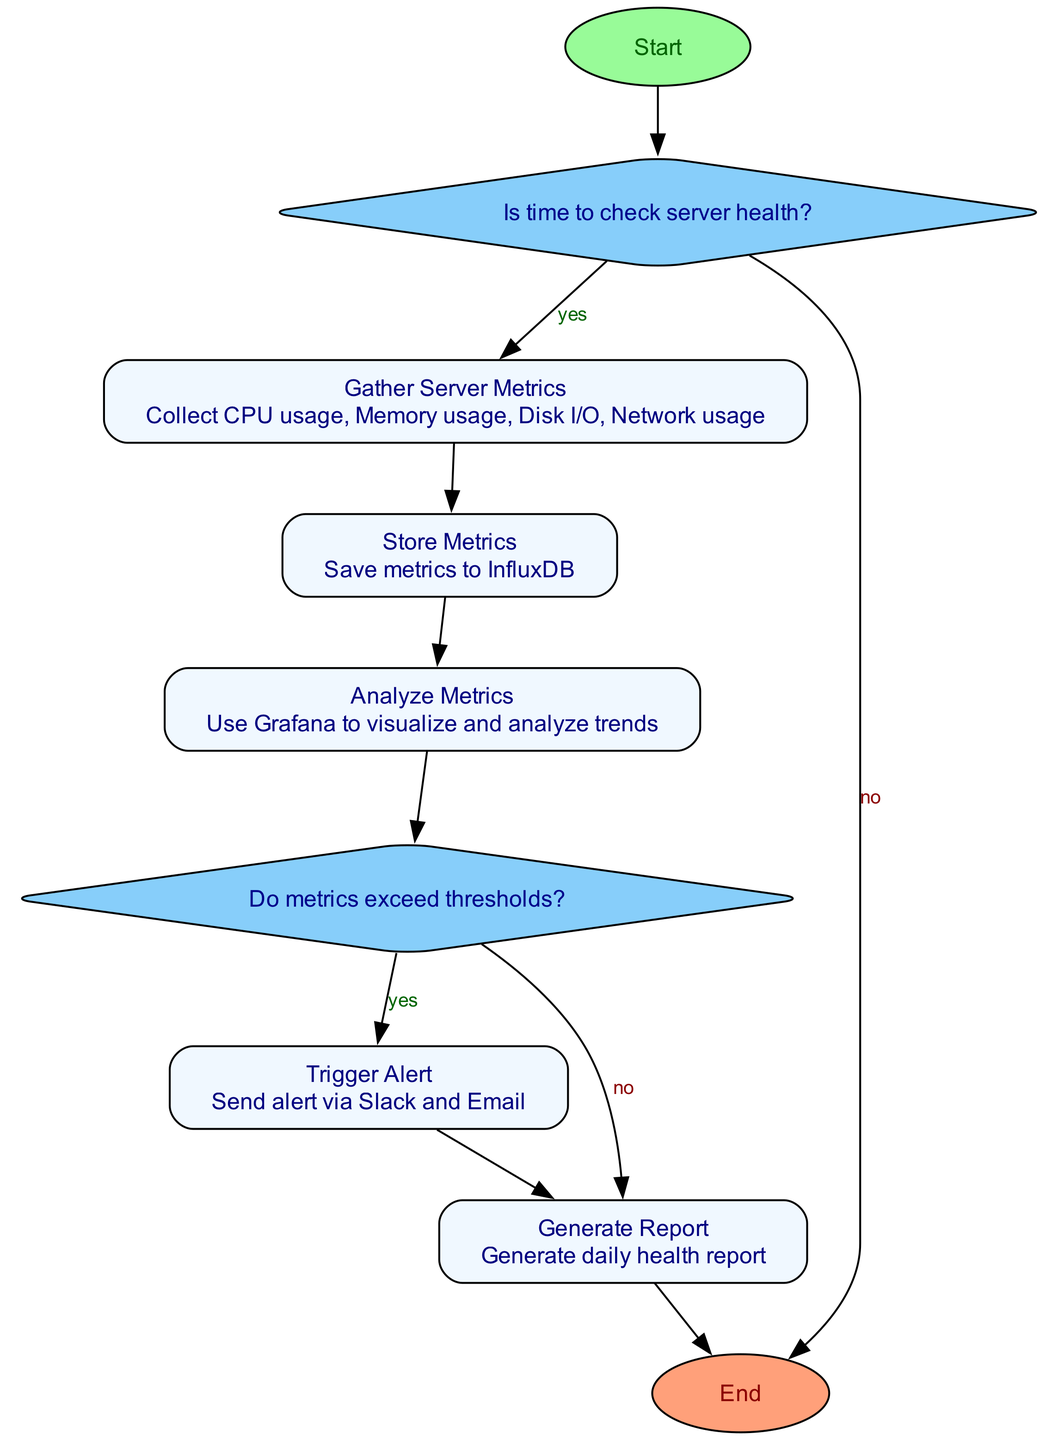What is the first step in the diagram? The first step is represented by the 'Start' node, which signifies the beginning of the process.
Answer: Start How many decision nodes are there in the diagram? There are two decision nodes: "Is time to check server health?" and "Do metrics exceed thresholds?"
Answer: 2 What happens when it is not time to check server health? If it is not time to check server health, the flow proceeds directly to the 'End' node, indicating the termination of the process.
Answer: End What does the 'Gather Server Metrics' process collect? The 'Gather Server Metrics' process collects CPU usage, Memory usage, Disk I/O, and Network usage as specified in its description.
Answer: CPU usage, Memory usage, Disk I/O, Network usage If metrics exceed thresholds, what is the next process to execute? If the metrics exceed thresholds, the flow continues to the 'Trigger Alert' process, which is responsible for sending alerts.
Answer: Trigger Alert Which process is responsible for visualizing and analyzing trends? The 'Analyze Metrics' process uses Grafana to visualize and analyze trends, as indicated in its description.
Answer: Analyze Metrics What is the final process before reaching the 'End'? The final process before reaching the 'End' is 'Generate Report', which is executed after either analyzing metrics or triggering an alert.
Answer: Generate Report How many processes are there in total in this diagram? There are five processes: 'Gather Server Metrics', 'Store Metrics', 'Analyze Metrics', 'Trigger Alert', and 'Generate Report'.
Answer: 5 